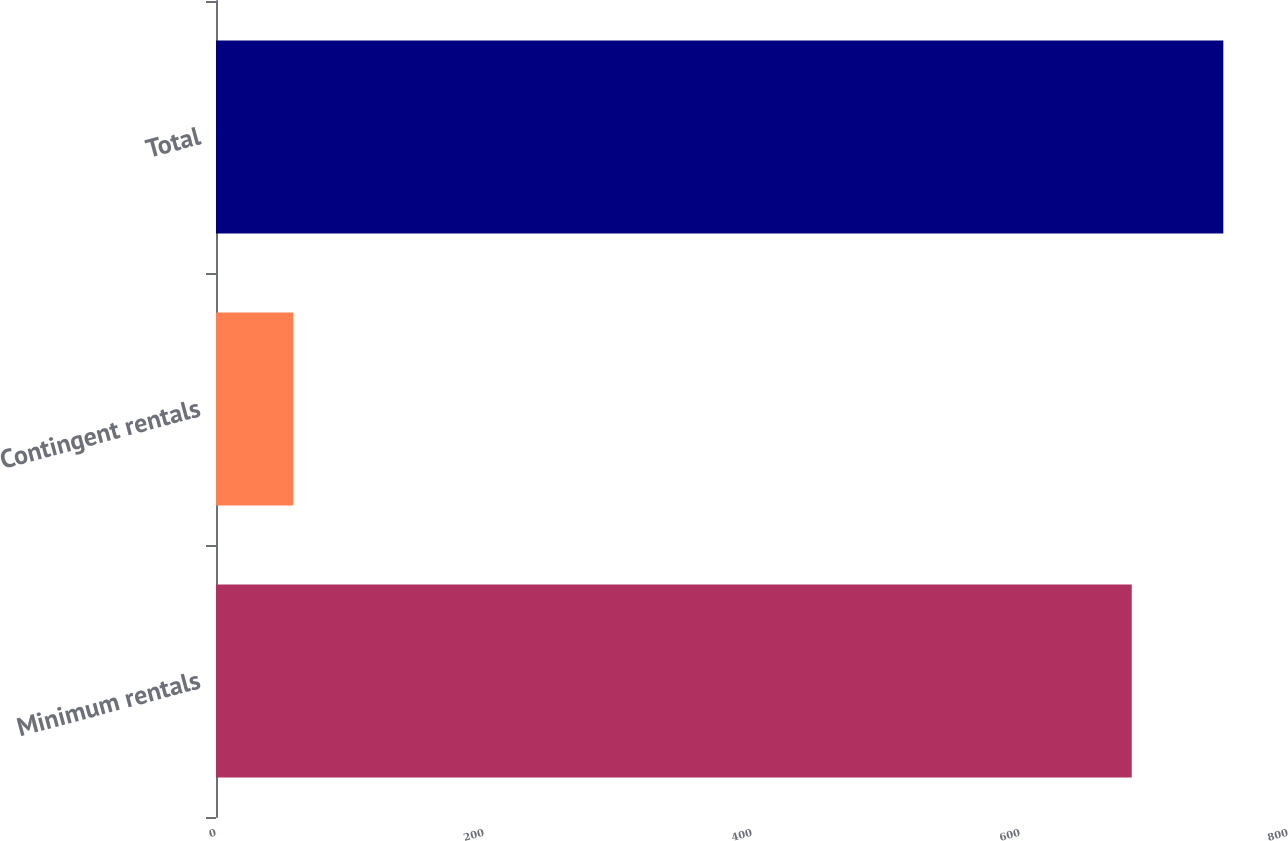Convert chart to OTSL. <chart><loc_0><loc_0><loc_500><loc_500><bar_chart><fcel>Minimum rentals<fcel>Contingent rentals<fcel>Total<nl><fcel>683.4<fcel>57.7<fcel>751.74<nl></chart> 